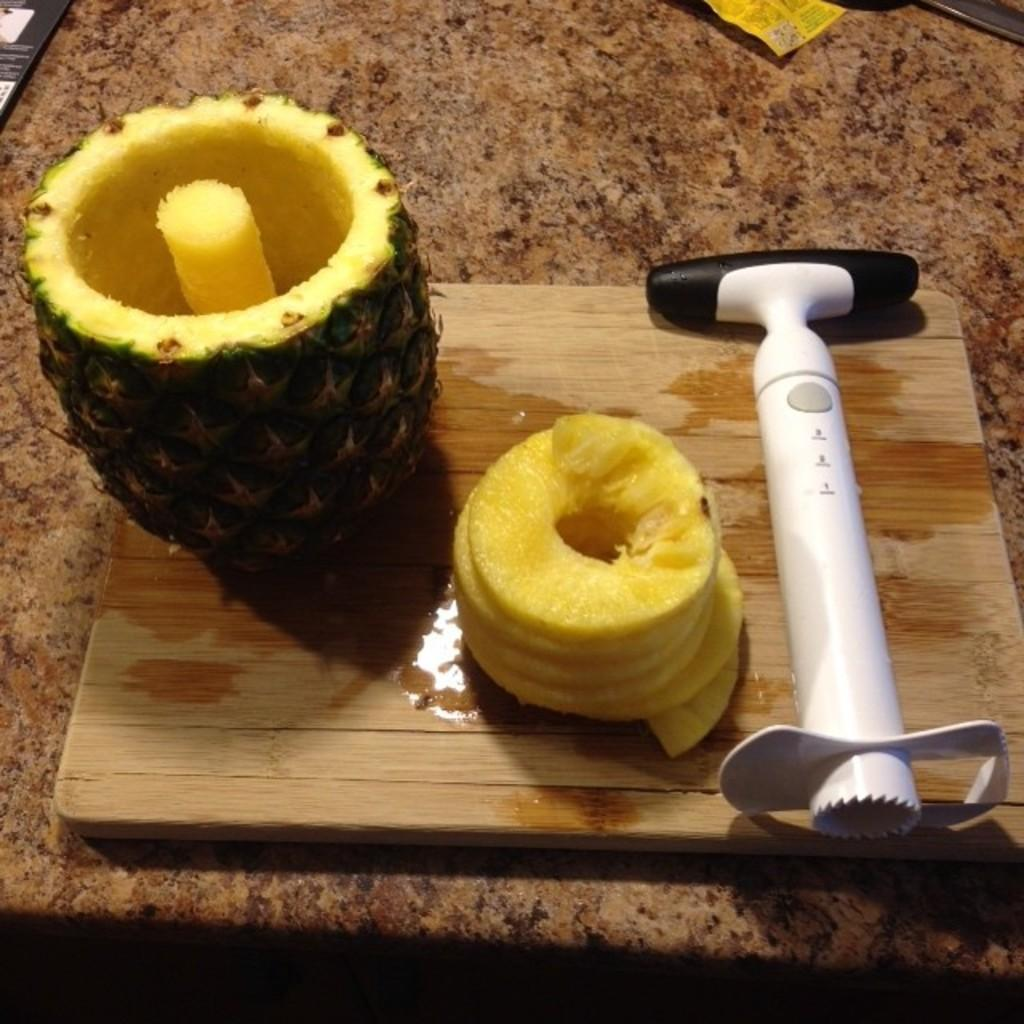What is the main subject of the image? There is a pineapple in the image. How is the pineapple positioned in the image? The pineapple is on a wooden board. What is the color of the pineapple? The pineapple is yellow in color. What other object is on the wooden board? There is a white object on the wooden board. What is the color of the surface the wooden board is on? The wooden board is on a brown surface. What time does the clock show in the image? There is no clock present in the image, so it is not possible to determine the time. 